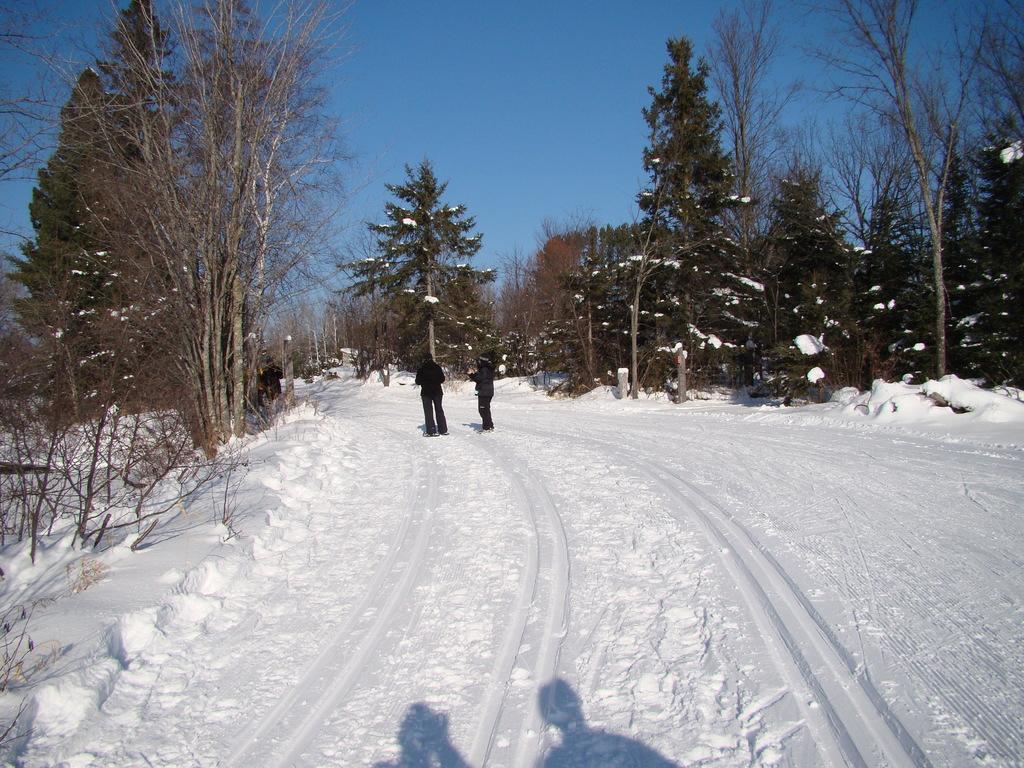Can you describe this image briefly? In this image I can see few people standing on the snow. These people are wearing the black color dress. To the side there are many trees. In the back I can see the sky. 